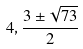<formula> <loc_0><loc_0><loc_500><loc_500>4 , \frac { 3 \pm \sqrt { 7 3 } } { 2 }</formula> 